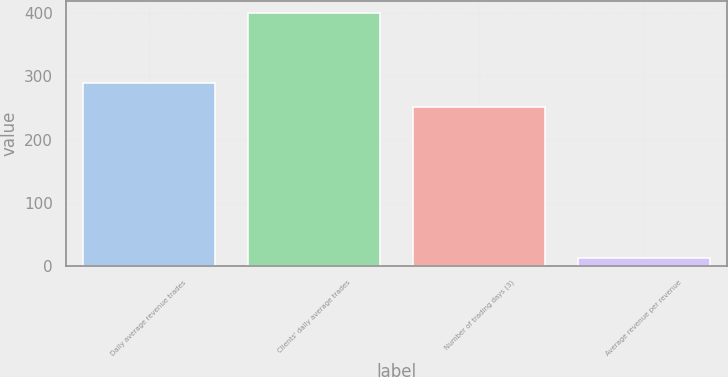Convert chart. <chart><loc_0><loc_0><loc_500><loc_500><bar_chart><fcel>Daily average revenue trades<fcel>Clients' daily average trades<fcel>Number of trading days (3)<fcel>Average revenue per revenue<nl><fcel>290.24<fcel>399.7<fcel>251.5<fcel>12.28<nl></chart> 